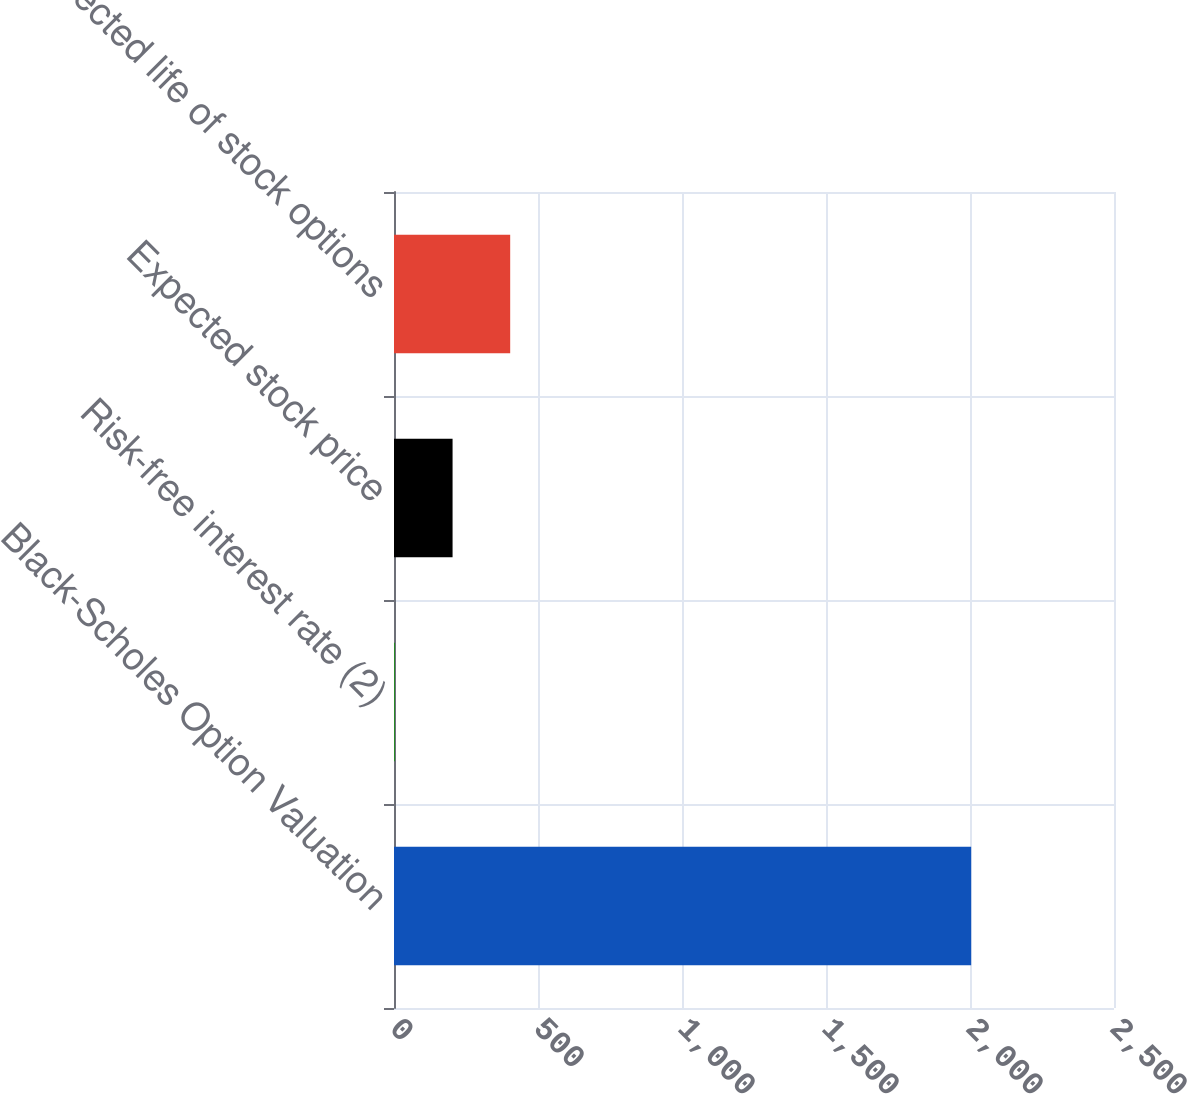<chart> <loc_0><loc_0><loc_500><loc_500><bar_chart><fcel>Black-Scholes Option Valuation<fcel>Risk-free interest rate (2)<fcel>Expected stock price<fcel>Expected life of stock options<nl><fcel>2004<fcel>3.3<fcel>203.37<fcel>403.44<nl></chart> 